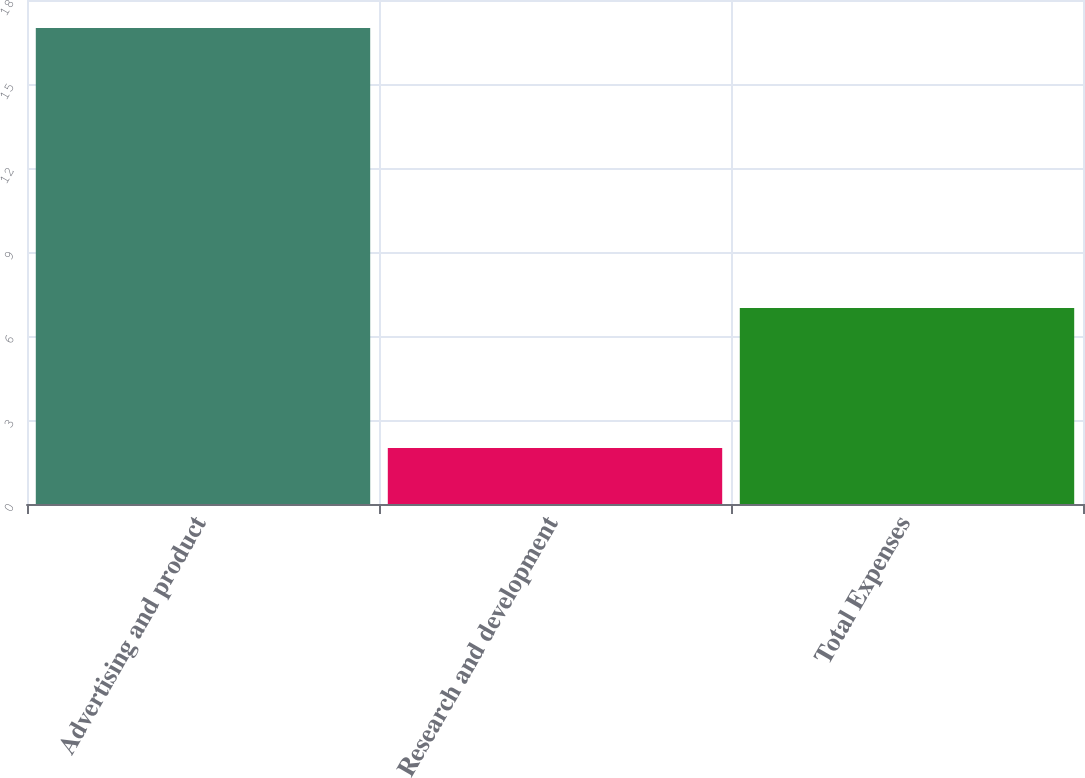<chart> <loc_0><loc_0><loc_500><loc_500><bar_chart><fcel>Advertising and product<fcel>Research and development<fcel>Total Expenses<nl><fcel>17<fcel>2<fcel>7<nl></chart> 